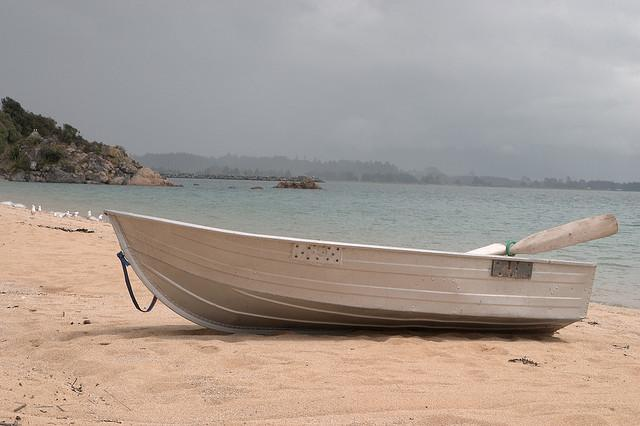What propels this boat? Please explain your reasoning. oar. The boat is very basic and the only tool present is an oar. 